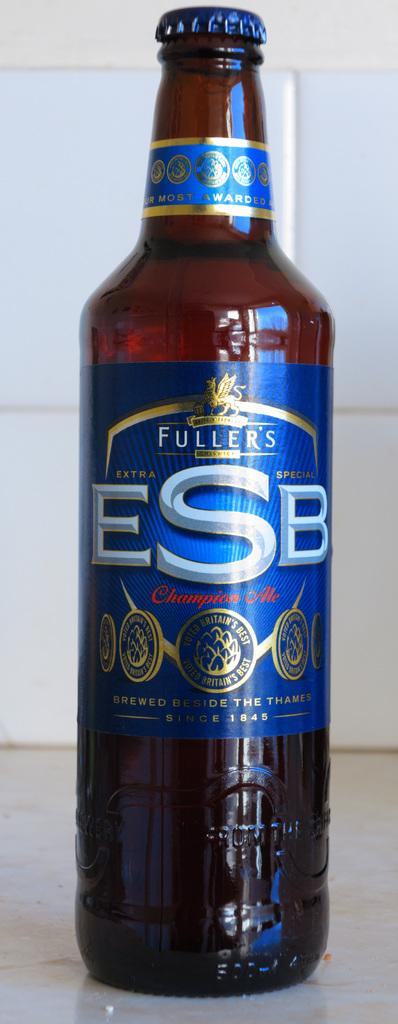Provide a one-sentence caption for the provided image. Bottle of Fuller's ESB beer on top of a table. 